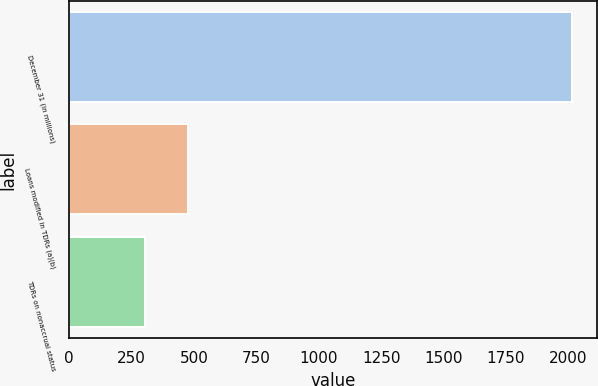Convert chart. <chart><loc_0><loc_0><loc_500><loc_500><bar_chart><fcel>December 31 (in millions)<fcel>Loans modified in TDRs (a)(b)<fcel>TDRs on nonaccrual status<nl><fcel>2014<fcel>476.8<fcel>306<nl></chart> 